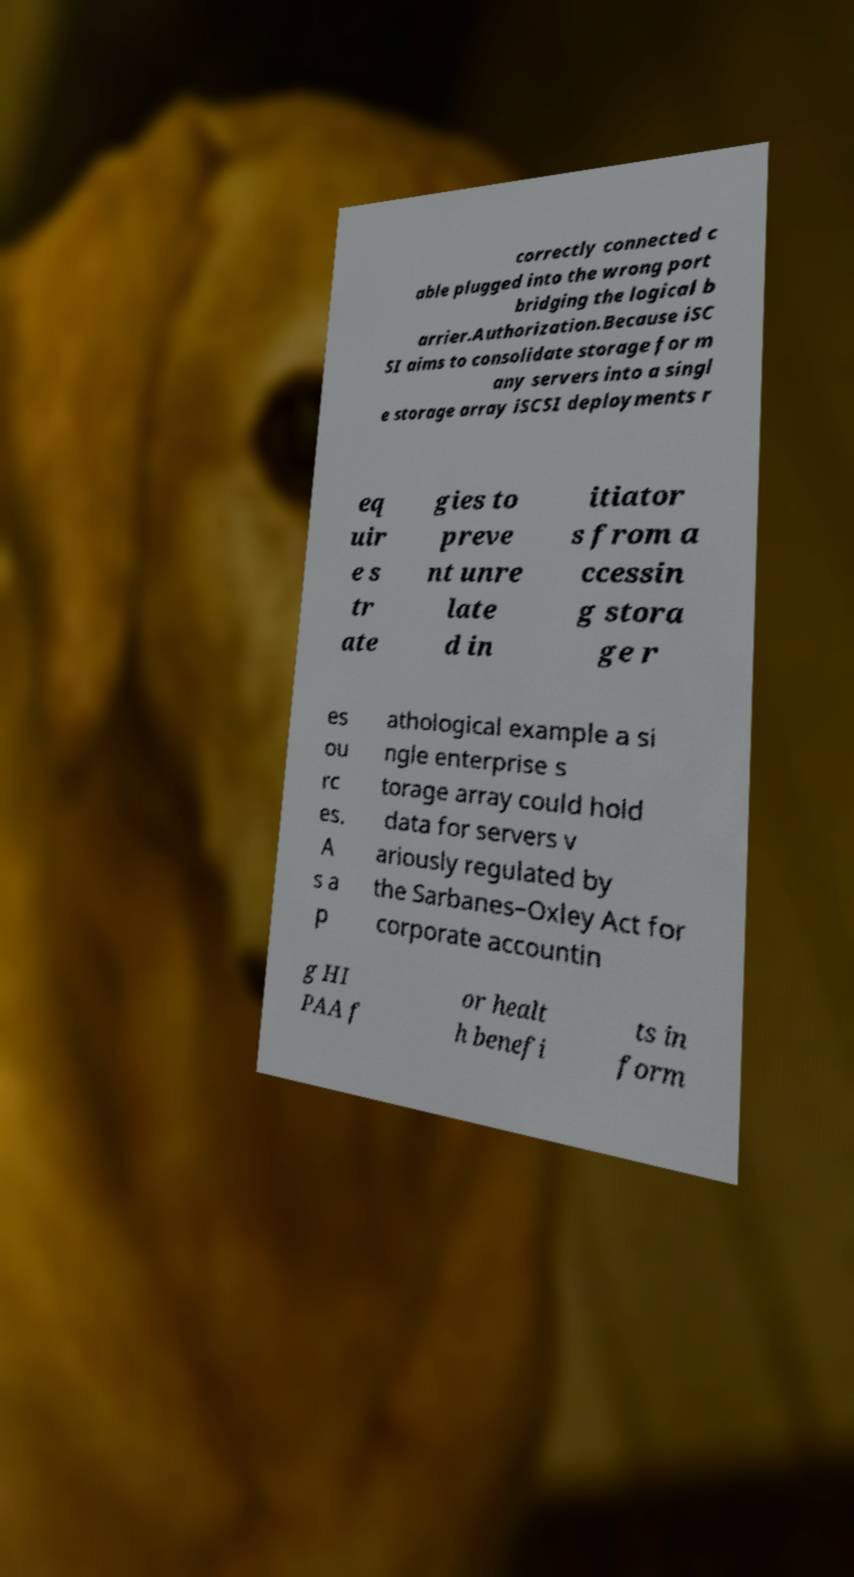Could you extract and type out the text from this image? correctly connected c able plugged into the wrong port bridging the logical b arrier.Authorization.Because iSC SI aims to consolidate storage for m any servers into a singl e storage array iSCSI deployments r eq uir e s tr ate gies to preve nt unre late d in itiator s from a ccessin g stora ge r es ou rc es. A s a p athological example a si ngle enterprise s torage array could hold data for servers v ariously regulated by the Sarbanes–Oxley Act for corporate accountin g HI PAA f or healt h benefi ts in form 